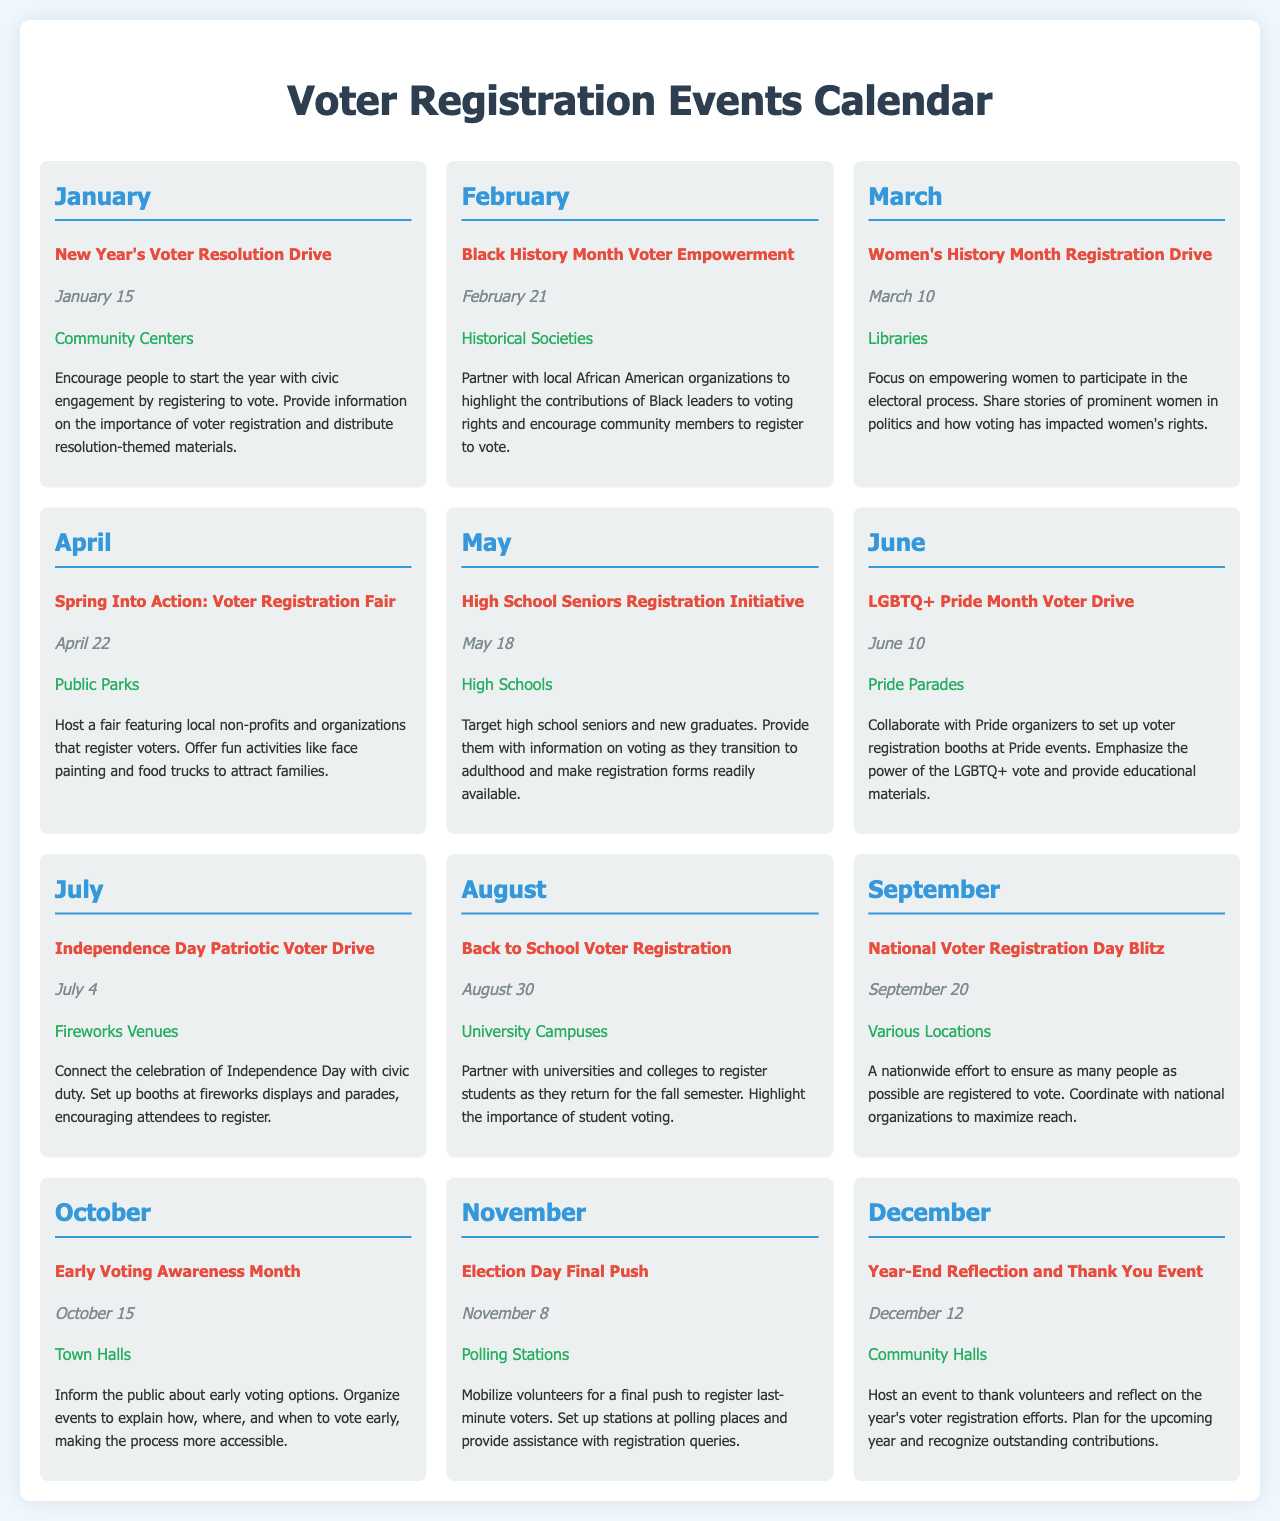What is the name of the event in January? The event name is listed under January, focusing on New Year's civic engagement.
Answer: New Year's Voter Resolution Drive When is the Women's History Month Registration Drive scheduled? The date for this event is specified in March, under the relevant month.
Answer: March 10 What location is associated with the July event? The document specifies that the event happens at venues during July associated with Independence Day celebrations.
Answer: Fireworks Venues Which month features the National Voter Registration Day Blitz? This event is detailed in the September section of the calendar.
Answer: September What type of organizations are involved in the April event? The April event includes collaboration with local non-profits and organizations focused on registering voters.
Answer: Local non-profits How many events are listed in the calendar? The calendar lists a total of 12 distinct events corresponding to each month of the year.
Answer: 12 What is the focus of the August event? The focus is on student engagement as universities reopen for the fall semester.
Answer: Back to School Voter Registration Which event is scheduled for December, and what is its purpose? This event is designated for December and aims to reflect on the year's efforts and thank volunteers.
Answer: Year-End Reflection and Thank You Event What time of year is considered for early voting awareness? The document emphasizes early voting awareness in October.
Answer: October 